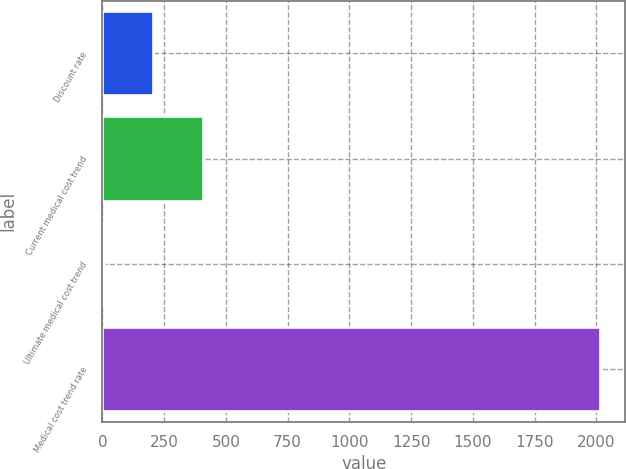Convert chart to OTSL. <chart><loc_0><loc_0><loc_500><loc_500><bar_chart><fcel>Discount rate<fcel>Current medical cost trend<fcel>Ultimate medical cost trend<fcel>Medical cost trend rate<nl><fcel>205.88<fcel>407<fcel>4.75<fcel>2016<nl></chart> 